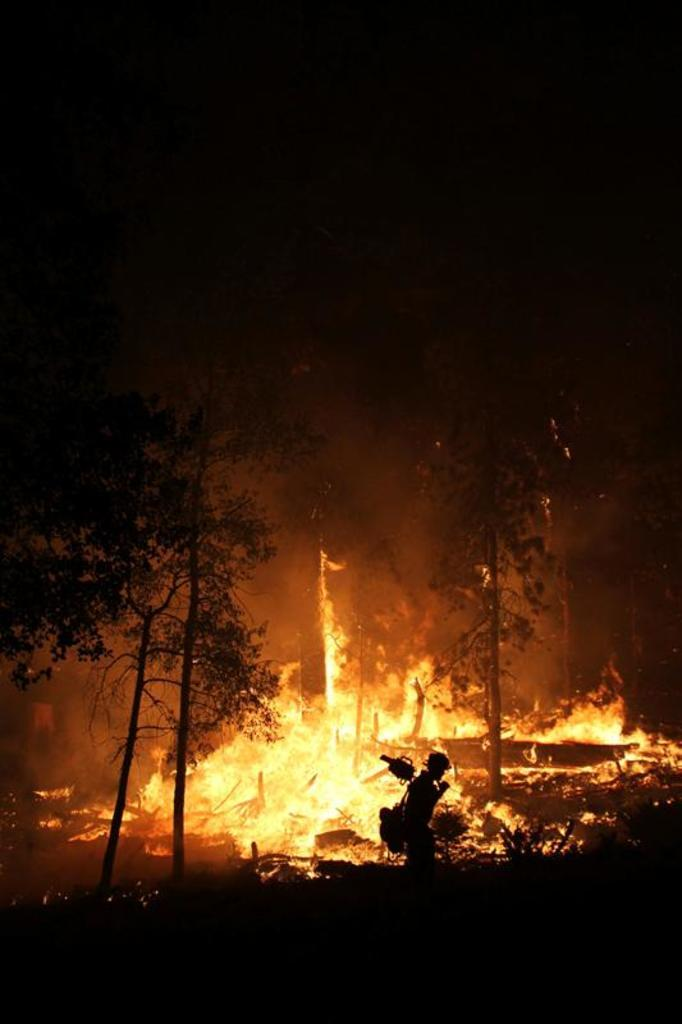Who or what is present in the image? There is a person in the image. What is the person holding or carrying? The person is carrying a bag. What type of natural environment is visible in the image? There are trees in the image. What can be seen in the background of the image? There is fire visible in the background of the image. What type of hen can be seen telling a joke in the image? There is no hen or joke present in the image. 